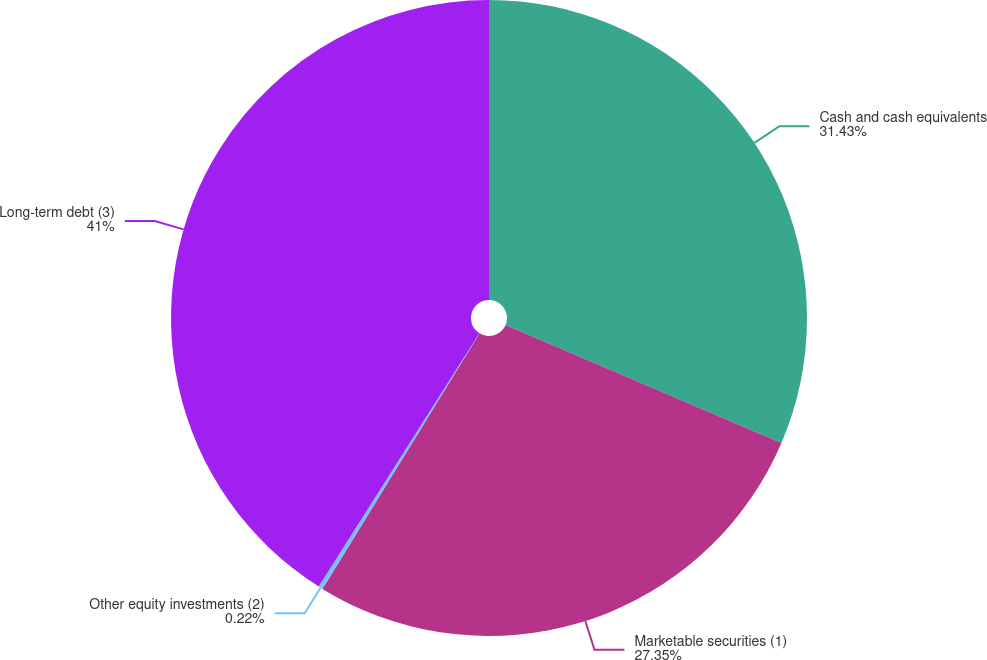Convert chart to OTSL. <chart><loc_0><loc_0><loc_500><loc_500><pie_chart><fcel>Cash and cash equivalents<fcel>Marketable securities (1)<fcel>Other equity investments (2)<fcel>Long-term debt (3)<nl><fcel>31.43%<fcel>27.35%<fcel>0.22%<fcel>41.01%<nl></chart> 